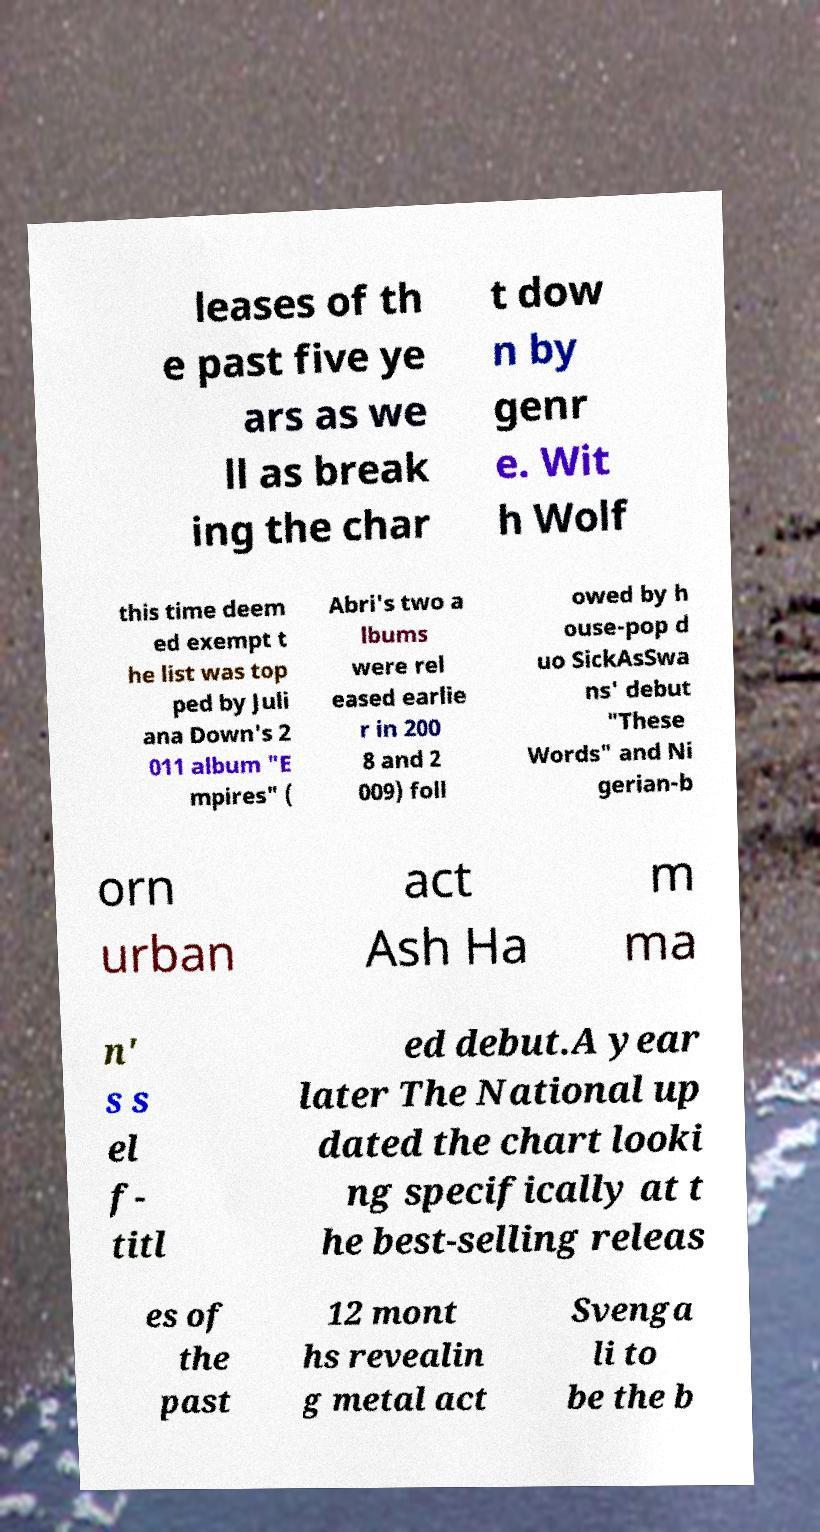What messages or text are displayed in this image? I need them in a readable, typed format. leases of th e past five ye ars as we ll as break ing the char t dow n by genr e. Wit h Wolf this time deem ed exempt t he list was top ped by Juli ana Down's 2 011 album "E mpires" ( Abri's two a lbums were rel eased earlie r in 200 8 and 2 009) foll owed by h ouse-pop d uo SickAsSwa ns' debut "These Words" and Ni gerian-b orn urban act Ash Ha m ma n' s s el f- titl ed debut.A year later The National up dated the chart looki ng specifically at t he best-selling releas es of the past 12 mont hs revealin g metal act Svenga li to be the b 